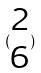<formula> <loc_0><loc_0><loc_500><loc_500>( \begin{matrix} 2 \\ 6 \end{matrix} )</formula> 